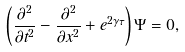Convert formula to latex. <formula><loc_0><loc_0><loc_500><loc_500>\left ( \frac { \partial ^ { 2 } } { \partial t ^ { 2 } } - \frac { \partial ^ { 2 } } { \partial x ^ { 2 } } + e ^ { 2 \gamma \tau } \right ) \Psi = 0 ,</formula> 